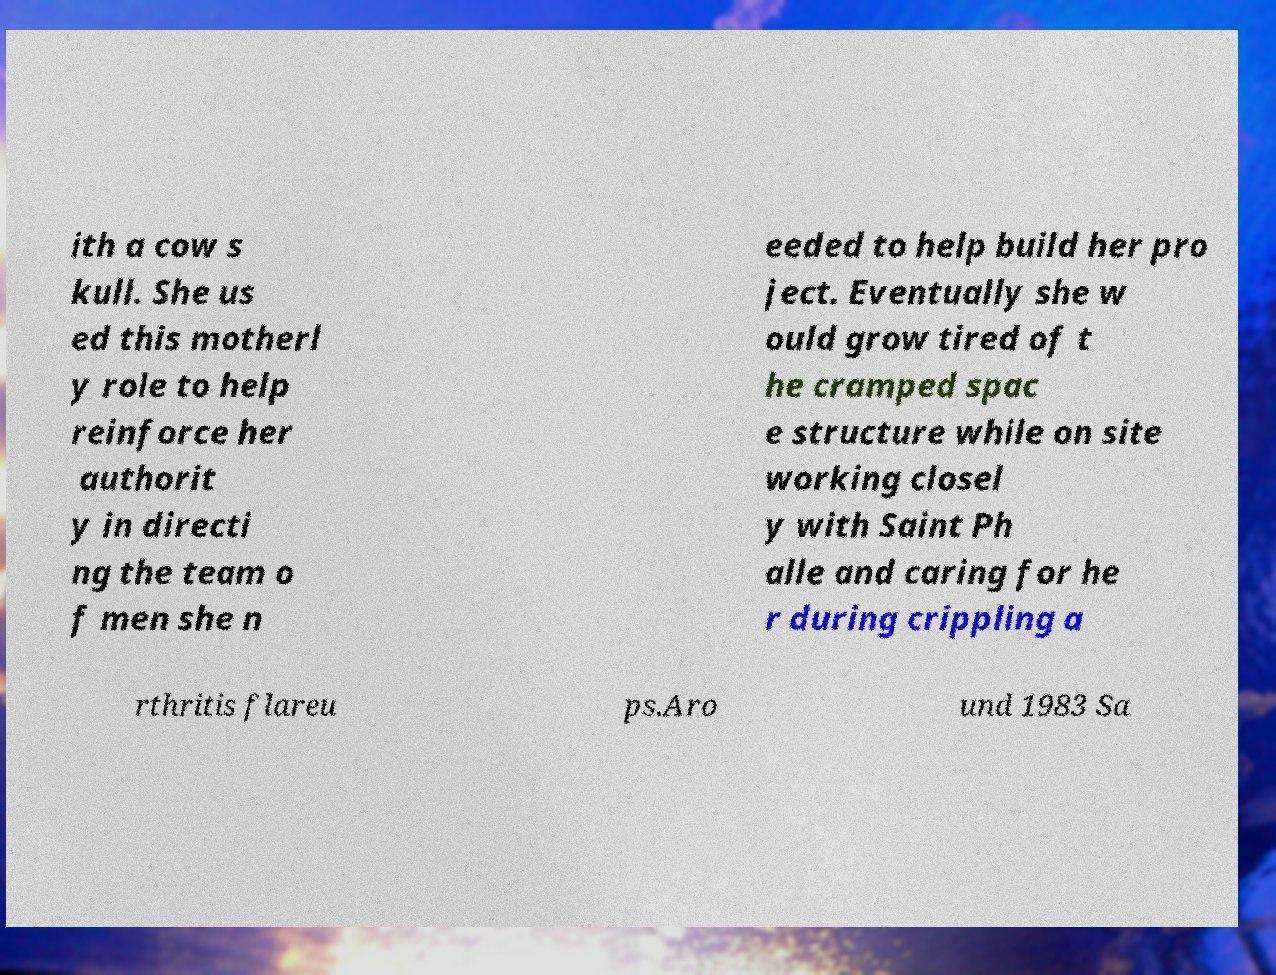There's text embedded in this image that I need extracted. Can you transcribe it verbatim? ith a cow s kull. She us ed this motherl y role to help reinforce her authorit y in directi ng the team o f men she n eeded to help build her pro ject. Eventually she w ould grow tired of t he cramped spac e structure while on site working closel y with Saint Ph alle and caring for he r during crippling a rthritis flareu ps.Aro und 1983 Sa 